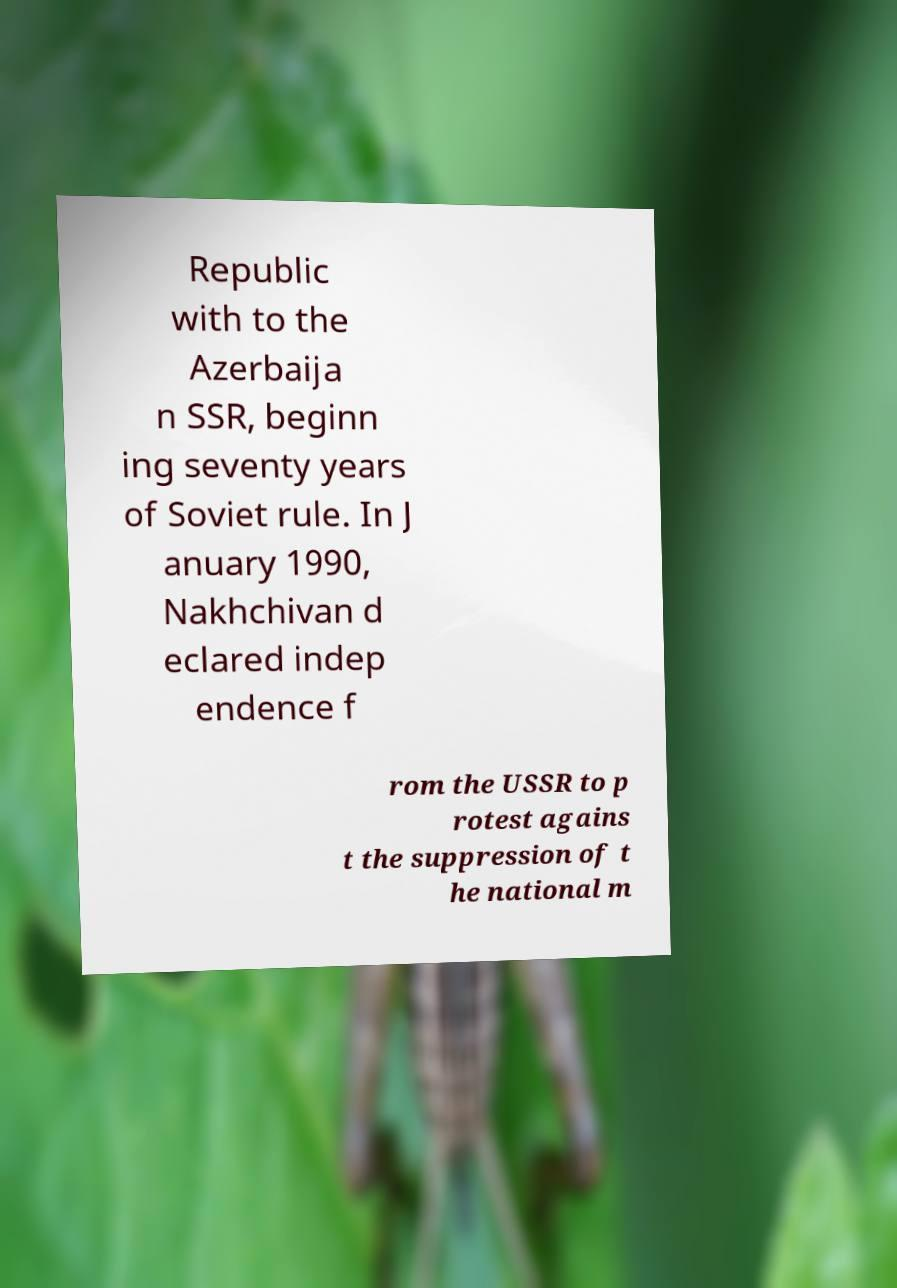I need the written content from this picture converted into text. Can you do that? Republic with to the Azerbaija n SSR, beginn ing seventy years of Soviet rule. In J anuary 1990, Nakhchivan d eclared indep endence f rom the USSR to p rotest agains t the suppression of t he national m 